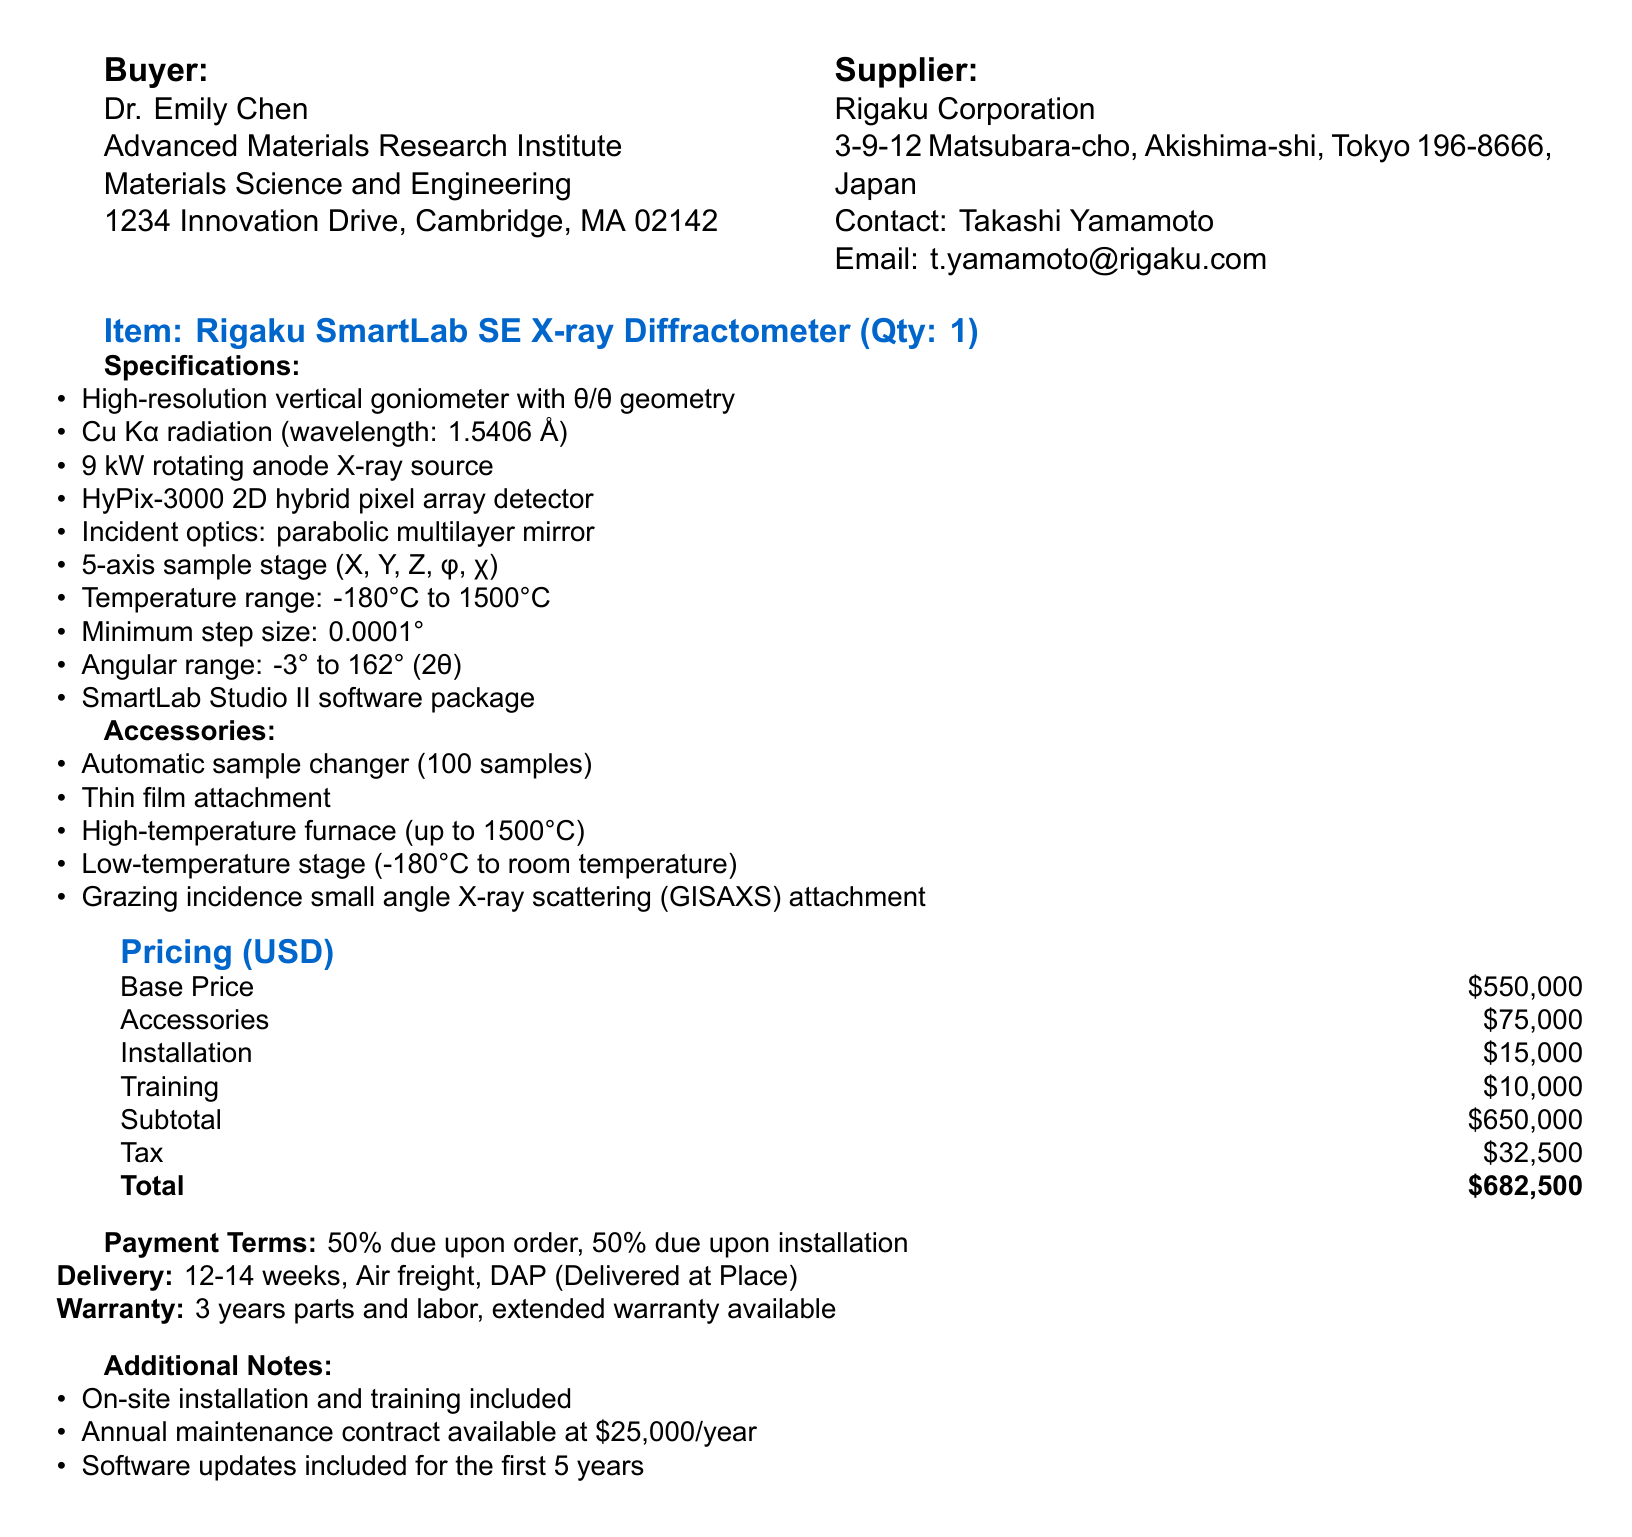What is the order number? The order number is listed at the top of the document, indicating the specific purchase order for tracking.
Answer: PO-2023-XRD-001 Who is the supplier's contact person? The supplier's contact person is mentioned in the supplier section of the document for communication purposes.
Answer: Takashi Yamamoto What is the base price of the X-ray diffractometer? The base price is clearly stated in the pricing section, representing the cost of the main item.
Answer: 550000 What is the total cost including tax? The total cost is the final amount after including base price, accessories, installation, training, and tax, detailed in the pricing section.
Answer: 682500 What is the warranty period for the equipment? The warranty period is specified, providing information on the duration of coverage offered for the purchase.
Answer: 3 years How many accessories are included with the X-ray diffractometer? The accessories section lists individual items and their details, which help assess the total number of extras provided.
Answer: 5 What is the payment term structure? The payment terms specify how and when payments must be made as part of the purchase agreement.
Answer: 50% due upon order, 50% due upon installation What is the delivery method for the order? The delivery terms section outlines the method selected for shipping the purchased equipment.
Answer: Air freight What additional service is available after the purchase? Additional notes include services offered post-purchase, detailing ongoing support for the equipment.
Answer: Annual maintenance contract available 